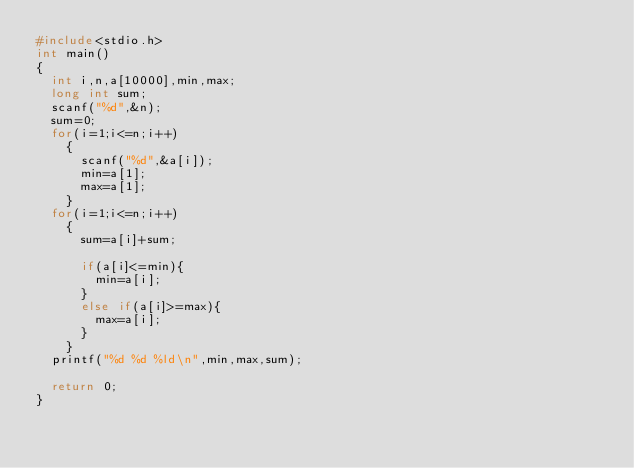<code> <loc_0><loc_0><loc_500><loc_500><_C_>#include<stdio.h>
int main()
{
  int i,n,a[10000],min,max;
  long int sum;
  scanf("%d",&n);
  sum=0;
  for(i=1;i<=n;i++)
    {
      scanf("%d",&a[i]);
      min=a[1];
      max=a[1];
    }
  for(i=1;i<=n;i++)
    {
      sum=a[i]+sum;

      if(a[i]<=min){
        min=a[i];
      }
      else if(a[i]>=max){
        max=a[i];
      }
    }
  printf("%d %d %ld\n",min,max,sum);

  return 0;
}

</code> 